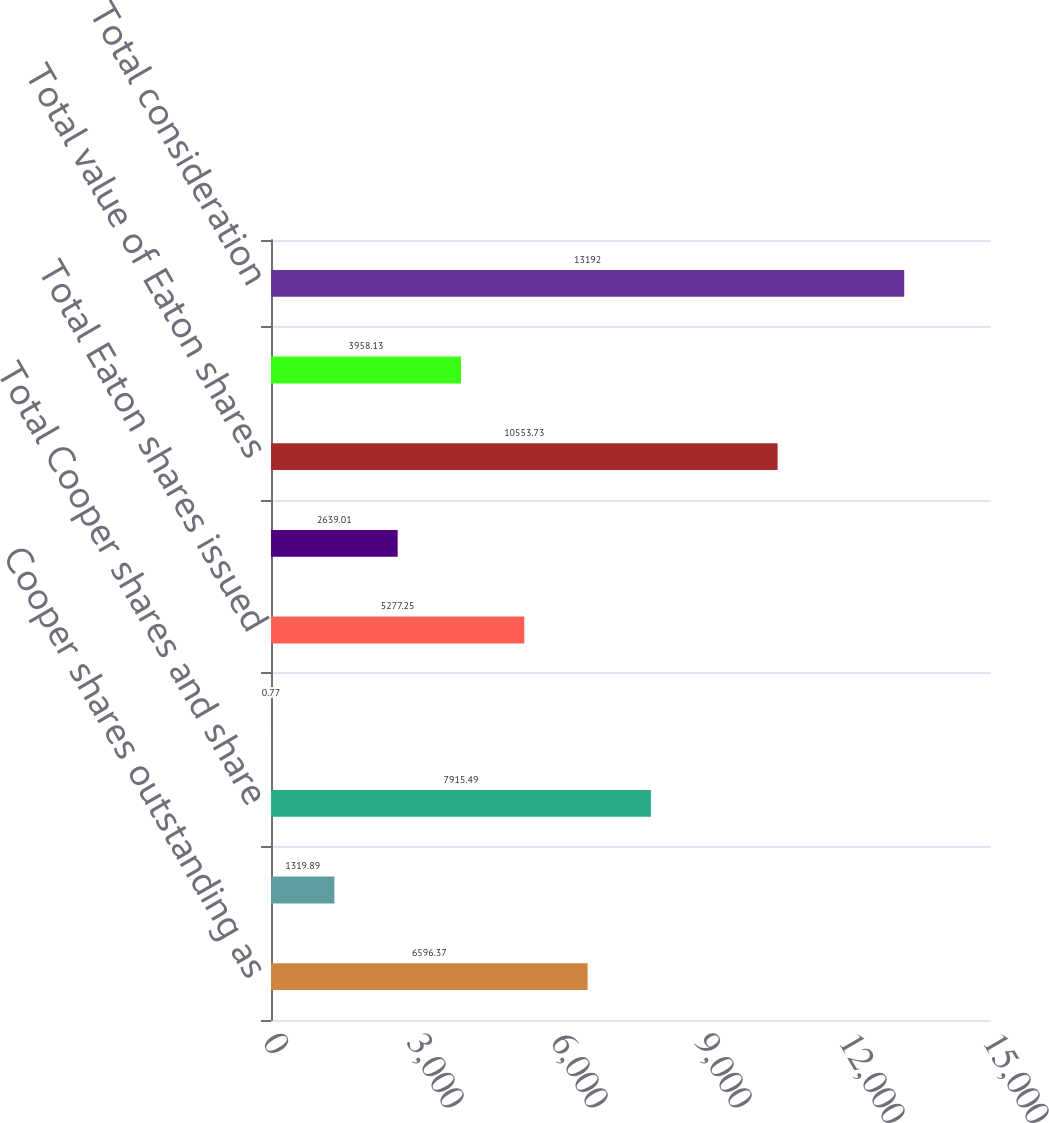Convert chart. <chart><loc_0><loc_0><loc_500><loc_500><bar_chart><fcel>Cooper shares outstanding as<fcel>Cooper shares issued pursuant<fcel>Total Cooper shares and share<fcel>Exchange ratio per share<fcel>Total Eaton shares issued<fcel>Weighted-average Eaton<fcel>Total value of Eaton shares<fcel>Total cash consideration paid<fcel>Total consideration<nl><fcel>6596.37<fcel>1319.89<fcel>7915.49<fcel>0.77<fcel>5277.25<fcel>2639.01<fcel>10553.7<fcel>3958.13<fcel>13192<nl></chart> 